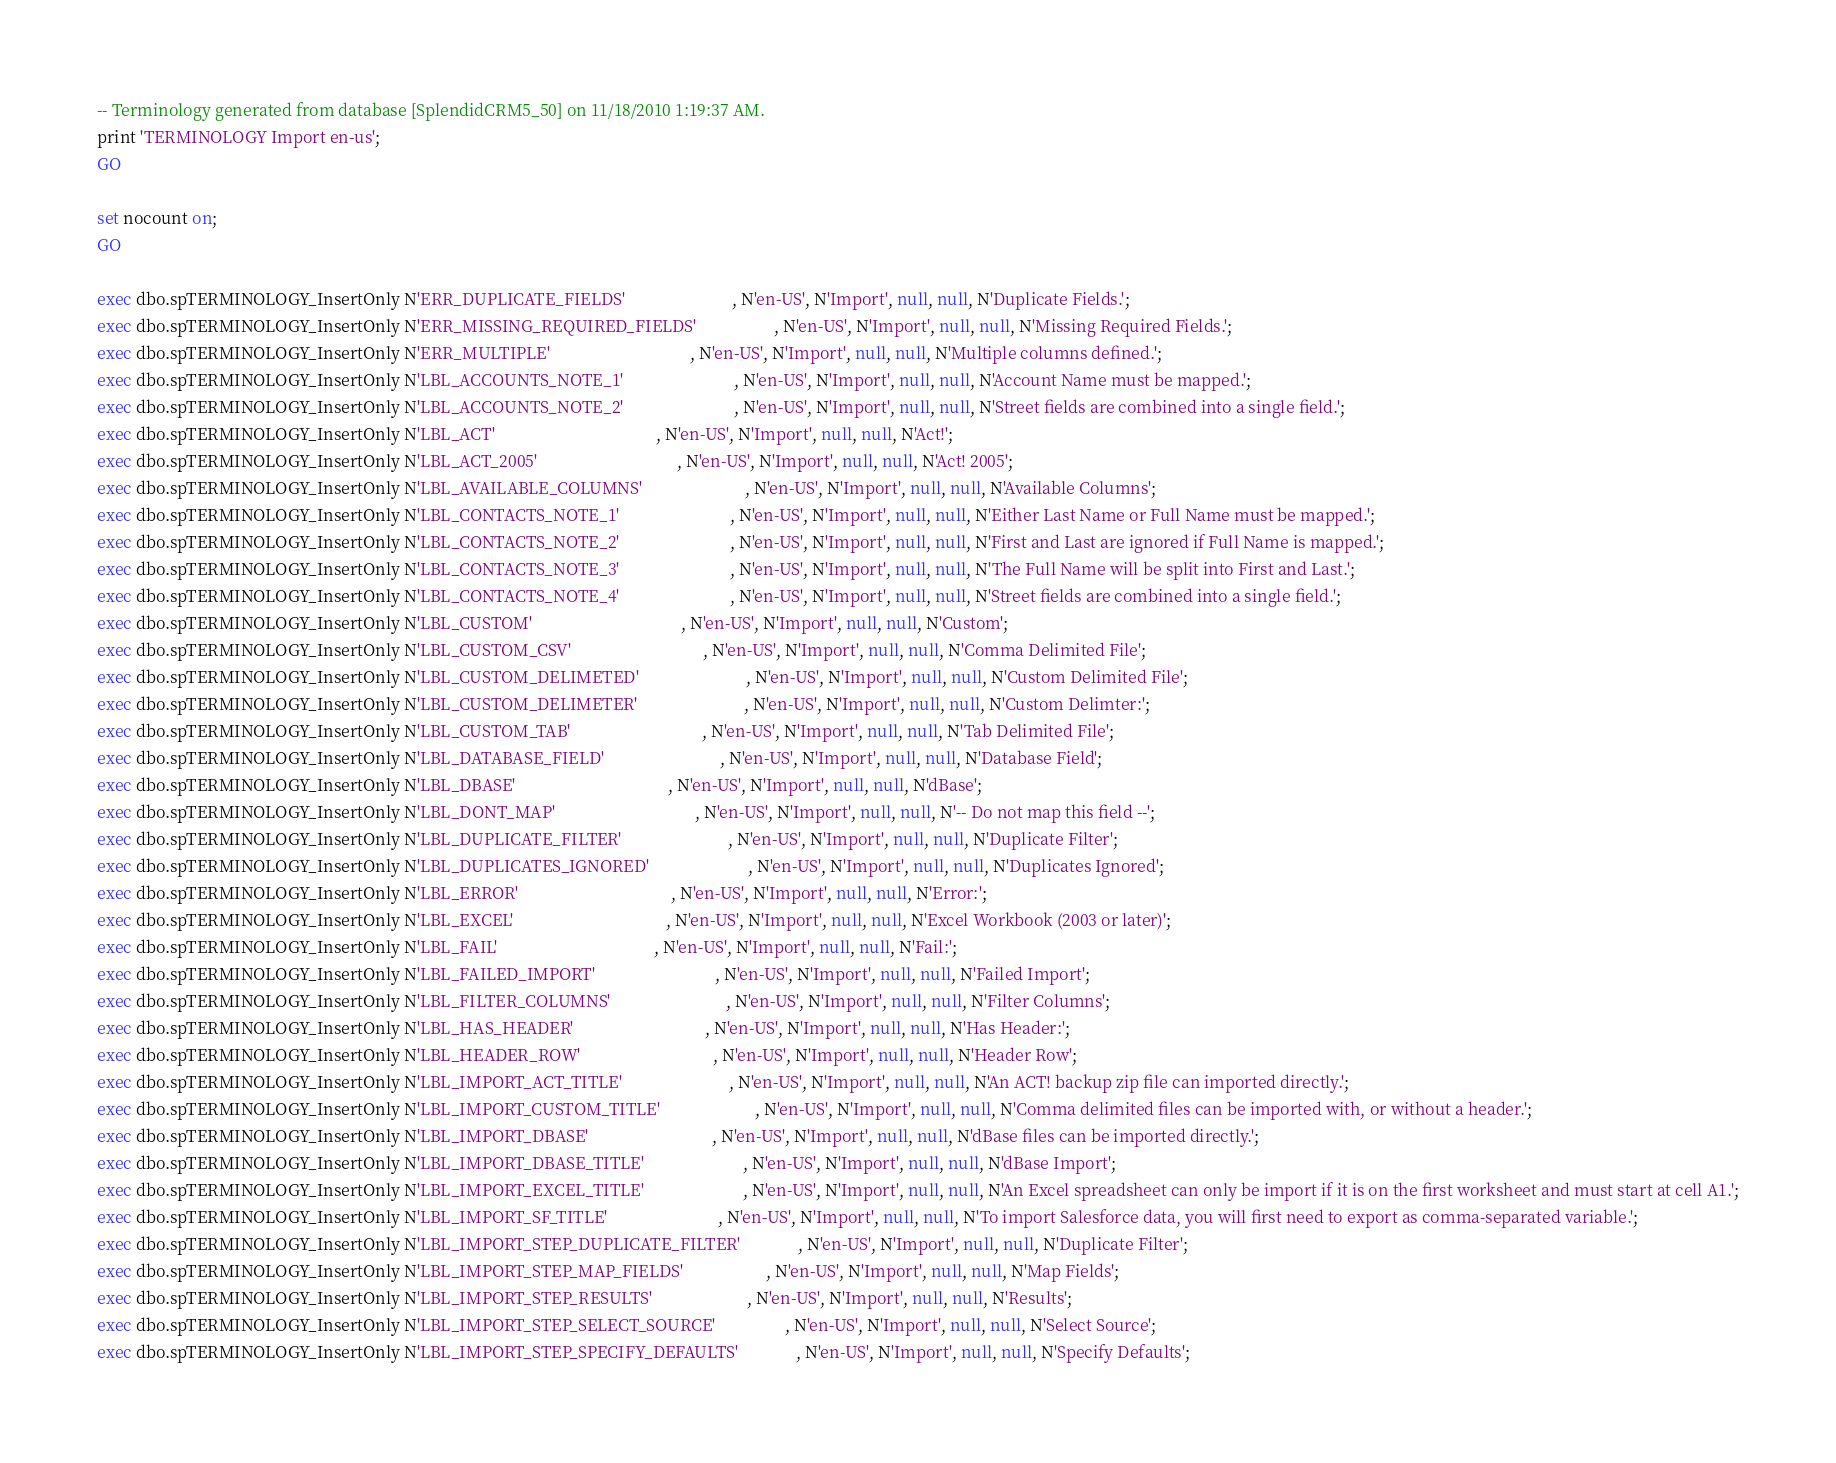<code> <loc_0><loc_0><loc_500><loc_500><_SQL_>

-- Terminology generated from database [SplendidCRM5_50] on 11/18/2010 1:19:37 AM.
print 'TERMINOLOGY Import en-us';
GO

set nocount on;
GO

exec dbo.spTERMINOLOGY_InsertOnly N'ERR_DUPLICATE_FIELDS'                          , N'en-US', N'Import', null, null, N'Duplicate Fields.';
exec dbo.spTERMINOLOGY_InsertOnly N'ERR_MISSING_REQUIRED_FIELDS'                   , N'en-US', N'Import', null, null, N'Missing Required Fields.';
exec dbo.spTERMINOLOGY_InsertOnly N'ERR_MULTIPLE'                                  , N'en-US', N'Import', null, null, N'Multiple columns defined.';
exec dbo.spTERMINOLOGY_InsertOnly N'LBL_ACCOUNTS_NOTE_1'                           , N'en-US', N'Import', null, null, N'Account Name must be mapped.';
exec dbo.spTERMINOLOGY_InsertOnly N'LBL_ACCOUNTS_NOTE_2'                           , N'en-US', N'Import', null, null, N'Street fields are combined into a single field.';
exec dbo.spTERMINOLOGY_InsertOnly N'LBL_ACT'                                       , N'en-US', N'Import', null, null, N'Act!';
exec dbo.spTERMINOLOGY_InsertOnly N'LBL_ACT_2005'                                  , N'en-US', N'Import', null, null, N'Act! 2005';
exec dbo.spTERMINOLOGY_InsertOnly N'LBL_AVAILABLE_COLUMNS'                         , N'en-US', N'Import', null, null, N'Available Columns';
exec dbo.spTERMINOLOGY_InsertOnly N'LBL_CONTACTS_NOTE_1'                           , N'en-US', N'Import', null, null, N'Either Last Name or Full Name must be mapped.';
exec dbo.spTERMINOLOGY_InsertOnly N'LBL_CONTACTS_NOTE_2'                           , N'en-US', N'Import', null, null, N'First and Last are ignored if Full Name is mapped.';
exec dbo.spTERMINOLOGY_InsertOnly N'LBL_CONTACTS_NOTE_3'                           , N'en-US', N'Import', null, null, N'The Full Name will be split into First and Last.';
exec dbo.spTERMINOLOGY_InsertOnly N'LBL_CONTACTS_NOTE_4'                           , N'en-US', N'Import', null, null, N'Street fields are combined into a single field.';
exec dbo.spTERMINOLOGY_InsertOnly N'LBL_CUSTOM'                                    , N'en-US', N'Import', null, null, N'Custom';
exec dbo.spTERMINOLOGY_InsertOnly N'LBL_CUSTOM_CSV'                                , N'en-US', N'Import', null, null, N'Comma Delimited File';
exec dbo.spTERMINOLOGY_InsertOnly N'LBL_CUSTOM_DELIMETED'                          , N'en-US', N'Import', null, null, N'Custom Delimited File';
exec dbo.spTERMINOLOGY_InsertOnly N'LBL_CUSTOM_DELIMETER'                          , N'en-US', N'Import', null, null, N'Custom Delimter:';
exec dbo.spTERMINOLOGY_InsertOnly N'LBL_CUSTOM_TAB'                                , N'en-US', N'Import', null, null, N'Tab Delimited File';
exec dbo.spTERMINOLOGY_InsertOnly N'LBL_DATABASE_FIELD'                            , N'en-US', N'Import', null, null, N'Database Field';
exec dbo.spTERMINOLOGY_InsertOnly N'LBL_DBASE'                                     , N'en-US', N'Import', null, null, N'dBase';
exec dbo.spTERMINOLOGY_InsertOnly N'LBL_DONT_MAP'                                  , N'en-US', N'Import', null, null, N'-- Do not map this field --';
exec dbo.spTERMINOLOGY_InsertOnly N'LBL_DUPLICATE_FILTER'                          , N'en-US', N'Import', null, null, N'Duplicate Filter';
exec dbo.spTERMINOLOGY_InsertOnly N'LBL_DUPLICATES_IGNORED'                        , N'en-US', N'Import', null, null, N'Duplicates Ignored';
exec dbo.spTERMINOLOGY_InsertOnly N'LBL_ERROR'                                     , N'en-US', N'Import', null, null, N'Error:';
exec dbo.spTERMINOLOGY_InsertOnly N'LBL_EXCEL'                                     , N'en-US', N'Import', null, null, N'Excel Workbook (2003 or later)';
exec dbo.spTERMINOLOGY_InsertOnly N'LBL_FAIL'                                      , N'en-US', N'Import', null, null, N'Fail:';
exec dbo.spTERMINOLOGY_InsertOnly N'LBL_FAILED_IMPORT'                             , N'en-US', N'Import', null, null, N'Failed Import';
exec dbo.spTERMINOLOGY_InsertOnly N'LBL_FILTER_COLUMNS'                            , N'en-US', N'Import', null, null, N'Filter Columns';
exec dbo.spTERMINOLOGY_InsertOnly N'LBL_HAS_HEADER'                                , N'en-US', N'Import', null, null, N'Has Header:';
exec dbo.spTERMINOLOGY_InsertOnly N'LBL_HEADER_ROW'                                , N'en-US', N'Import', null, null, N'Header Row';
exec dbo.spTERMINOLOGY_InsertOnly N'LBL_IMPORT_ACT_TITLE'                          , N'en-US', N'Import', null, null, N'An ACT! backup zip file can imported directly.';
exec dbo.spTERMINOLOGY_InsertOnly N'LBL_IMPORT_CUSTOM_TITLE'                       , N'en-US', N'Import', null, null, N'Comma delimited files can be imported with, or without a header.';
exec dbo.spTERMINOLOGY_InsertOnly N'LBL_IMPORT_DBASE'                              , N'en-US', N'Import', null, null, N'dBase files can be imported directly.';
exec dbo.spTERMINOLOGY_InsertOnly N'LBL_IMPORT_DBASE_TITLE'                        , N'en-US', N'Import', null, null, N'dBase Import';
exec dbo.spTERMINOLOGY_InsertOnly N'LBL_IMPORT_EXCEL_TITLE'                        , N'en-US', N'Import', null, null, N'An Excel spreadsheet can only be import if it is on the first worksheet and must start at cell A1.';
exec dbo.spTERMINOLOGY_InsertOnly N'LBL_IMPORT_SF_TITLE'                           , N'en-US', N'Import', null, null, N'To import Salesforce data, you will first need to export as comma-separated variable.';
exec dbo.spTERMINOLOGY_InsertOnly N'LBL_IMPORT_STEP_DUPLICATE_FILTER'              , N'en-US', N'Import', null, null, N'Duplicate Filter';
exec dbo.spTERMINOLOGY_InsertOnly N'LBL_IMPORT_STEP_MAP_FIELDS'                    , N'en-US', N'Import', null, null, N'Map Fields';
exec dbo.spTERMINOLOGY_InsertOnly N'LBL_IMPORT_STEP_RESULTS'                       , N'en-US', N'Import', null, null, N'Results';
exec dbo.spTERMINOLOGY_InsertOnly N'LBL_IMPORT_STEP_SELECT_SOURCE'                 , N'en-US', N'Import', null, null, N'Select Source';
exec dbo.spTERMINOLOGY_InsertOnly N'LBL_IMPORT_STEP_SPECIFY_DEFAULTS'              , N'en-US', N'Import', null, null, N'Specify Defaults';</code> 